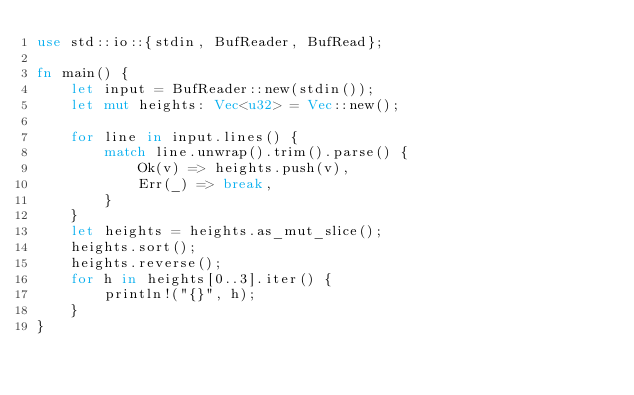Convert code to text. <code><loc_0><loc_0><loc_500><loc_500><_Rust_>use std::io::{stdin, BufReader, BufRead};

fn main() {
    let input = BufReader::new(stdin());
    let mut heights: Vec<u32> = Vec::new();

    for line in input.lines() {
        match line.unwrap().trim().parse() {
            Ok(v) => heights.push(v),
            Err(_) => break,
        }
    }
    let heights = heights.as_mut_slice();
    heights.sort();
    heights.reverse();
    for h in heights[0..3].iter() {
        println!("{}", h);
    }
}

</code> 